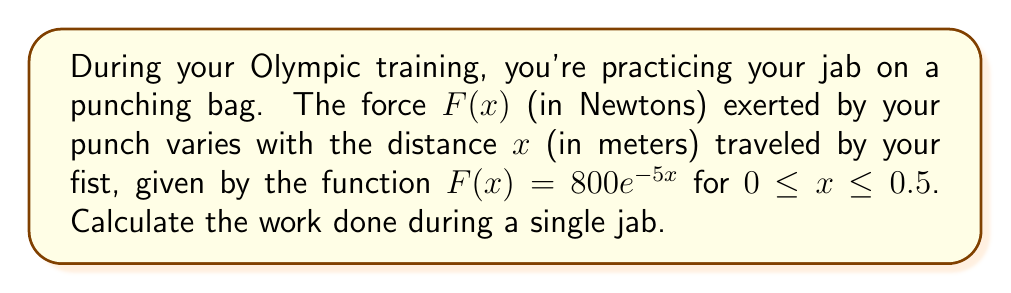Show me your answer to this math problem. To calculate the work done, we need to integrate the force function over the distance traveled:

1) The work $W$ is given by the integral:
   $$W = \int_{0}^{0.5} F(x) dx$$

2) Substituting the given force function:
   $$W = \int_{0}^{0.5} 800e^{-5x} dx$$

3) To integrate, we use the rule $\int e^{ax} dx = \frac{1}{a}e^{ax} + C$:
   $$W = 800 \int_{0}^{0.5} e^{-5x} dx = 800 \cdot \left[-\frac{1}{5}e^{-5x}\right]_{0}^{0.5}$$

4) Evaluating the integral:
   $$W = 800 \cdot \left(-\frac{1}{5}e^{-5(0.5)} - \left(-\frac{1}{5}e^{-5(0)}\right)\right)$$

5) Simplifying:
   $$W = 800 \cdot \left(-\frac{1}{5}e^{-2.5} + \frac{1}{5}\right)$$
   $$W = 160 \cdot (1 - e^{-2.5})$$

6) Computing the final value:
   $$W \approx 136.78 \text{ Joules}$$
Answer: $136.78 \text{ J}$ 